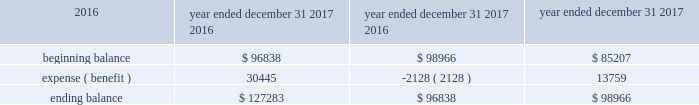Welltower inc .
Notes to consolidated financial statements is no longer present ( and additional weight may be given to subjective evidence such as our projections for growth ) .
The valuation allowance rollforward is summarized as follows for the periods presented ( in thousands ) : year ended december 31 , 2017 2016 2015 .
As a result of certain acquisitions , we are subject to corporate level taxes for any related asset dispositions that may occur during the five-year period immediately after such assets were owned by a c corporation ( 201cbuilt-in gains tax 201d ) .
The amount of income potentially subject to this special corporate level tax is generally equal to the lesser of ( a ) the excess of the fair value of the asset over its adjusted tax basis as of the date it became a reit asset , or ( b ) the actual amount of gain .
Some but not all gains recognized during this period of time could be offset by available net operating losses and capital loss carryforwards .
During the year ended december 31 , 2016 , we acquired certain additional assets with built-in gains as of the date of acquisition that could be subject to the built-in gains tax if disposed of prior to the expiration of the applicable ten-year period .
We have not recorded a deferred tax liability as a result of the potential built-in gains tax based on our intentions with respect to such properties and available tax planning strategies .
Under the provisions of the reit investment diversification and empowerment act of 2007 ( 201cridea 201d ) , for taxable years beginning after july 30 , 2008 , the reit may lease 201cqualified health care properties 201d on an arm 2019s-length basis to a trs if the property is operated on behalf of such subsidiary by a person who qualifies as an 201celigible independent contractor . 201d generally , the rent received from the trs will meet the related party rent exception and will be treated as 201crents from real property . 201d a 201cqualified health care property 201d includes real property and any personal property that is , or is necessary or incidental to the use of , a hospital , nursing facility , assisted living facility , congregate care facility , qualified continuing care facility , or other licensed facility which extends medical or nursing or ancillary services to patients .
We have entered into various joint ventures that were structured under ridea .
Resident level rents and related operating expenses for these facilities are reported in the consolidated financial statements and are subject to federal , state and foreign income taxes as the operations of such facilities are included in a trs .
Certain net operating loss carryforwards could be utilized to offset taxable income in future years .
Given the applicable statute of limitations , we generally are subject to audit by the internal revenue service ( 201cirs 201d ) for the year ended december 31 , 2014 and subsequent years .
The statute of limitations may vary in the states in which we own properties or conduct business .
We do not expect to be subject to audit by state taxing authorities for any year prior to the year ended december 31 , 2011 .
We are also subject to audit by the canada revenue agency and provincial authorities generally for periods subsequent to may 2012 related to entities acquired or formed in connection with acquisitions , and by the u.k . 2019s hm revenue & customs for periods subsequent to august 2012 related to entities acquired or formed in connection with acquisitions .
At december 31 , 2017 , we had a net operating loss ( 201cnol 201d ) carryforward related to the reit of $ 448475000 .
Due to our uncertainty regarding the realization of certain deferred tax assets , we have not recorded a deferred tax asset related to nols generated by the reit .
These amounts can be used to offset future taxable income ( and/or taxable income for prior years if an audit determines that tax is owed ) , if any .
The reit will be entitled to utilize nols and tax credit carryforwards only to the extent that reit taxable income exceeds our deduction for dividends paid .
The nol carryforwards generated through december 31 , 2017 will expire through 2036 .
Beginning with tax years after december 31 , 2017 , the tax cuts and jobs act ( 201ctax act 201d ) eliminates the carryback period , limits the nols to 80% ( 80 % ) of taxable income and replaces the 20-year carryforward period with an indefinite carryforward period. .
What is the percentage change in the balance valuation allowance rollforward during 2017? 
Computations: (30445 / 96838)
Answer: 0.31439. Welltower inc .
Notes to consolidated financial statements is no longer present ( and additional weight may be given to subjective evidence such as our projections for growth ) .
The valuation allowance rollforward is summarized as follows for the periods presented ( in thousands ) : year ended december 31 , 2017 2016 2015 .
As a result of certain acquisitions , we are subject to corporate level taxes for any related asset dispositions that may occur during the five-year period immediately after such assets were owned by a c corporation ( 201cbuilt-in gains tax 201d ) .
The amount of income potentially subject to this special corporate level tax is generally equal to the lesser of ( a ) the excess of the fair value of the asset over its adjusted tax basis as of the date it became a reit asset , or ( b ) the actual amount of gain .
Some but not all gains recognized during this period of time could be offset by available net operating losses and capital loss carryforwards .
During the year ended december 31 , 2016 , we acquired certain additional assets with built-in gains as of the date of acquisition that could be subject to the built-in gains tax if disposed of prior to the expiration of the applicable ten-year period .
We have not recorded a deferred tax liability as a result of the potential built-in gains tax based on our intentions with respect to such properties and available tax planning strategies .
Under the provisions of the reit investment diversification and empowerment act of 2007 ( 201cridea 201d ) , for taxable years beginning after july 30 , 2008 , the reit may lease 201cqualified health care properties 201d on an arm 2019s-length basis to a trs if the property is operated on behalf of such subsidiary by a person who qualifies as an 201celigible independent contractor . 201d generally , the rent received from the trs will meet the related party rent exception and will be treated as 201crents from real property . 201d a 201cqualified health care property 201d includes real property and any personal property that is , or is necessary or incidental to the use of , a hospital , nursing facility , assisted living facility , congregate care facility , qualified continuing care facility , or other licensed facility which extends medical or nursing or ancillary services to patients .
We have entered into various joint ventures that were structured under ridea .
Resident level rents and related operating expenses for these facilities are reported in the consolidated financial statements and are subject to federal , state and foreign income taxes as the operations of such facilities are included in a trs .
Certain net operating loss carryforwards could be utilized to offset taxable income in future years .
Given the applicable statute of limitations , we generally are subject to audit by the internal revenue service ( 201cirs 201d ) for the year ended december 31 , 2014 and subsequent years .
The statute of limitations may vary in the states in which we own properties or conduct business .
We do not expect to be subject to audit by state taxing authorities for any year prior to the year ended december 31 , 2011 .
We are also subject to audit by the canada revenue agency and provincial authorities generally for periods subsequent to may 2012 related to entities acquired or formed in connection with acquisitions , and by the u.k . 2019s hm revenue & customs for periods subsequent to august 2012 related to entities acquired or formed in connection with acquisitions .
At december 31 , 2017 , we had a net operating loss ( 201cnol 201d ) carryforward related to the reit of $ 448475000 .
Due to our uncertainty regarding the realization of certain deferred tax assets , we have not recorded a deferred tax asset related to nols generated by the reit .
These amounts can be used to offset future taxable income ( and/or taxable income for prior years if an audit determines that tax is owed ) , if any .
The reit will be entitled to utilize nols and tax credit carryforwards only to the extent that reit taxable income exceeds our deduction for dividends paid .
The nol carryforwards generated through december 31 , 2017 will expire through 2036 .
Beginning with tax years after december 31 , 2017 , the tax cuts and jobs act ( 201ctax act 201d ) eliminates the carryback period , limits the nols to 80% ( 80 % ) of taxable income and replaces the 20-year carryforward period with an indefinite carryforward period. .
For the year ended december 31 2017 , beginning balance is what percent of the ending balance? 
Computations: (96838 / 127283)
Answer: 0.76081. Welltower inc .
Notes to consolidated financial statements is no longer present ( and additional weight may be given to subjective evidence such as our projections for growth ) .
The valuation allowance rollforward is summarized as follows for the periods presented ( in thousands ) : year ended december 31 , 2017 2016 2015 .
As a result of certain acquisitions , we are subject to corporate level taxes for any related asset dispositions that may occur during the five-year period immediately after such assets were owned by a c corporation ( 201cbuilt-in gains tax 201d ) .
The amount of income potentially subject to this special corporate level tax is generally equal to the lesser of ( a ) the excess of the fair value of the asset over its adjusted tax basis as of the date it became a reit asset , or ( b ) the actual amount of gain .
Some but not all gains recognized during this period of time could be offset by available net operating losses and capital loss carryforwards .
During the year ended december 31 , 2016 , we acquired certain additional assets with built-in gains as of the date of acquisition that could be subject to the built-in gains tax if disposed of prior to the expiration of the applicable ten-year period .
We have not recorded a deferred tax liability as a result of the potential built-in gains tax based on our intentions with respect to such properties and available tax planning strategies .
Under the provisions of the reit investment diversification and empowerment act of 2007 ( 201cridea 201d ) , for taxable years beginning after july 30 , 2008 , the reit may lease 201cqualified health care properties 201d on an arm 2019s-length basis to a trs if the property is operated on behalf of such subsidiary by a person who qualifies as an 201celigible independent contractor . 201d generally , the rent received from the trs will meet the related party rent exception and will be treated as 201crents from real property . 201d a 201cqualified health care property 201d includes real property and any personal property that is , or is necessary or incidental to the use of , a hospital , nursing facility , assisted living facility , congregate care facility , qualified continuing care facility , or other licensed facility which extends medical or nursing or ancillary services to patients .
We have entered into various joint ventures that were structured under ridea .
Resident level rents and related operating expenses for these facilities are reported in the consolidated financial statements and are subject to federal , state and foreign income taxes as the operations of such facilities are included in a trs .
Certain net operating loss carryforwards could be utilized to offset taxable income in future years .
Given the applicable statute of limitations , we generally are subject to audit by the internal revenue service ( 201cirs 201d ) for the year ended december 31 , 2014 and subsequent years .
The statute of limitations may vary in the states in which we own properties or conduct business .
We do not expect to be subject to audit by state taxing authorities for any year prior to the year ended december 31 , 2011 .
We are also subject to audit by the canada revenue agency and provincial authorities generally for periods subsequent to may 2012 related to entities acquired or formed in connection with acquisitions , and by the u.k . 2019s hm revenue & customs for periods subsequent to august 2012 related to entities acquired or formed in connection with acquisitions .
At december 31 , 2017 , we had a net operating loss ( 201cnol 201d ) carryforward related to the reit of $ 448475000 .
Due to our uncertainty regarding the realization of certain deferred tax assets , we have not recorded a deferred tax asset related to nols generated by the reit .
These amounts can be used to offset future taxable income ( and/or taxable income for prior years if an audit determines that tax is owed ) , if any .
The reit will be entitled to utilize nols and tax credit carryforwards only to the extent that reit taxable income exceeds our deduction for dividends paid .
The nol carryforwards generated through december 31 , 2017 will expire through 2036 .
Beginning with tax years after december 31 , 2017 , the tax cuts and jobs act ( 201ctax act 201d ) eliminates the carryback period , limits the nols to 80% ( 80 % ) of taxable income and replaces the 20-year carryforward period with an indefinite carryforward period. .
What is the percentage change in the balance valuation allowance rollforward during 2016? 
Computations: (-2128 / 98966)
Answer: -0.0215. 